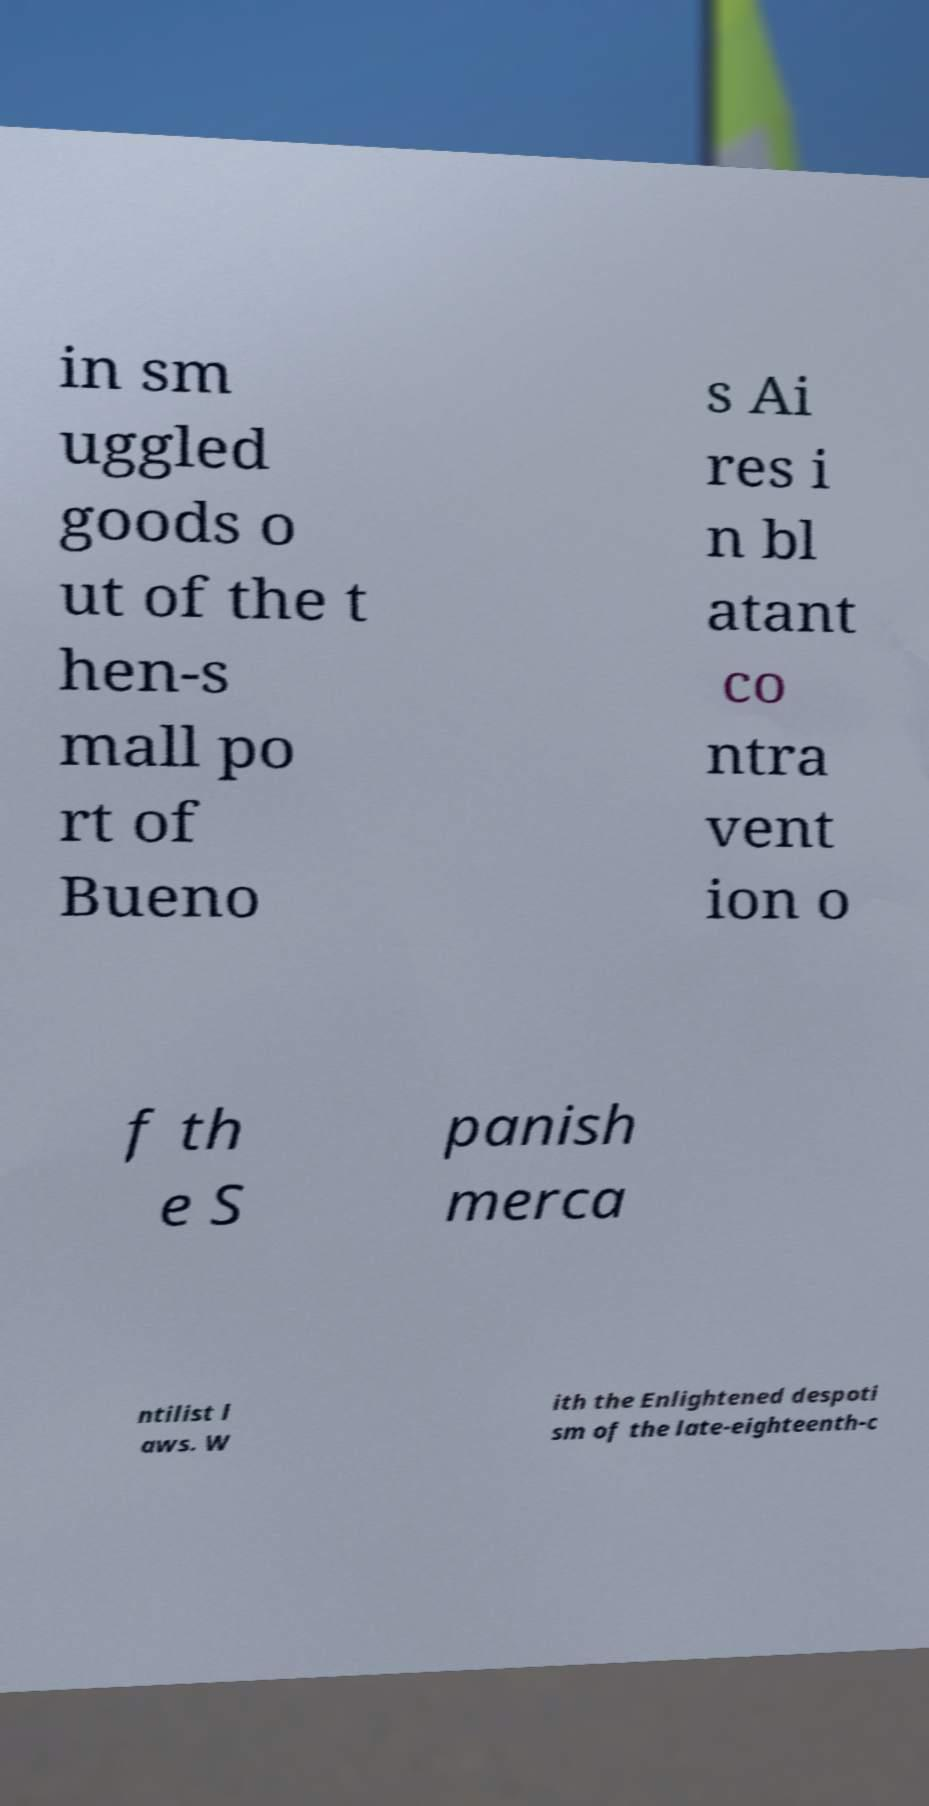What messages or text are displayed in this image? I need them in a readable, typed format. in sm uggled goods o ut of the t hen-s mall po rt of Bueno s Ai res i n bl atant co ntra vent ion o f th e S panish merca ntilist l aws. W ith the Enlightened despoti sm of the late-eighteenth-c 